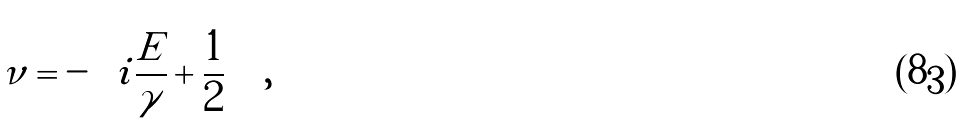Convert formula to latex. <formula><loc_0><loc_0><loc_500><loc_500>\nu = - \left ( i \frac { E } { \gamma } + \frac { 1 } { 2 } \right ) \ ,</formula> 